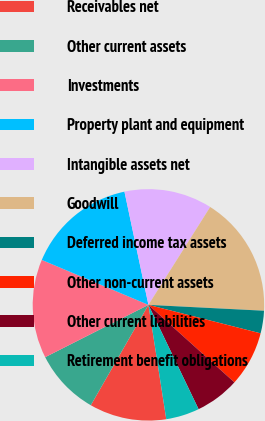<chart> <loc_0><loc_0><loc_500><loc_500><pie_chart><fcel>Receivables net<fcel>Other current assets<fcel>Investments<fcel>Property plant and equipment<fcel>Intangible assets net<fcel>Goodwill<fcel>Deferred income tax assets<fcel>Other non-current assets<fcel>Other current liabilities<fcel>Retirement benefit obligations<nl><fcel>10.76%<fcel>9.24%<fcel>13.81%<fcel>15.33%<fcel>12.28%<fcel>16.85%<fcel>3.15%<fcel>7.72%<fcel>6.19%<fcel>4.67%<nl></chart> 